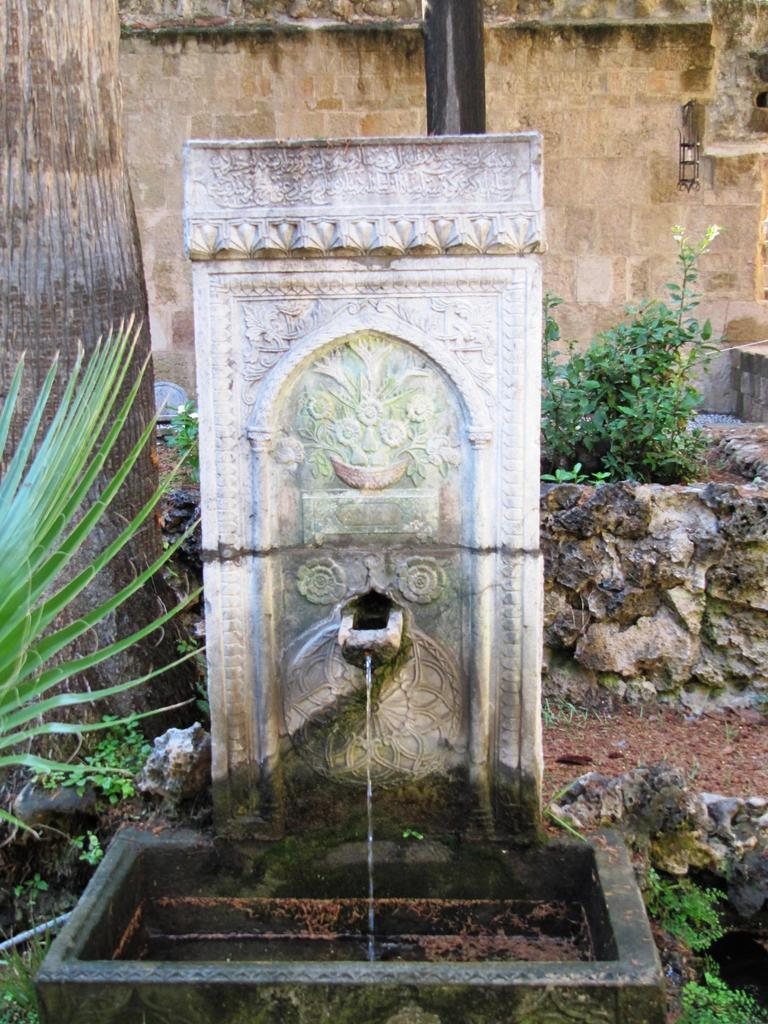What can be seen in the background of the image? There is a wall in the background of the image. What is located on the left side of the image? There is a tree trunk on the left side of the image. What is the main feature in the center of the image? There is a fountain in the center of the image. What type of bag is hanging from the tree trunk in the image? There is no bag present in the image; it features a tree trunk and a fountain. What rule is being enforced by the fountain in the image? There is no rule being enforced by the fountain in the image; it is simply a decorative feature. 